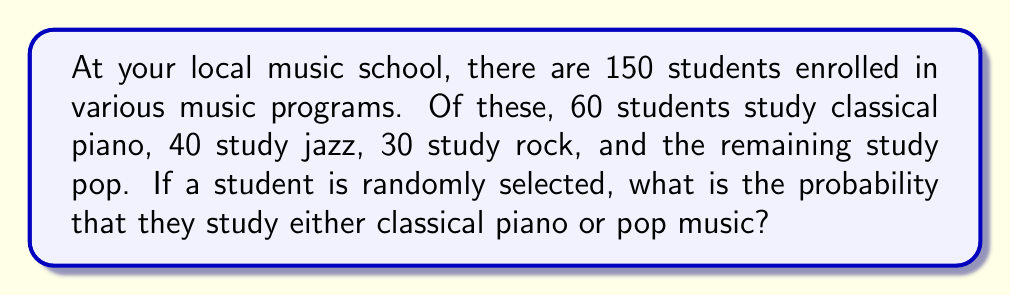Can you answer this question? Let's approach this step-by-step:

1. First, we need to determine how many students study pop music:
   Total students = 150
   Classical piano + Jazz + Rock + Pop = 150
   60 + 40 + 30 + Pop = 150
   Pop = 150 - 130 = 20 students

2. Now we know:
   Classical piano: 60 students
   Pop: 20 students

3. To find the probability of a student studying either classical piano or pop, we need to add these together:
   Students studying classical piano or pop = 60 + 20 = 80

4. The probability is calculated by dividing the number of favorable outcomes by the total number of possible outcomes:

   $$P(\text{Classical piano or Pop}) = \frac{\text{Number of students in Classical piano or Pop}}{\text{Total number of students}}$$

   $$P(\text{Classical piano or Pop}) = \frac{80}{150}$$

5. This fraction can be reduced:
   $$\frac{80}{150} = \frac{16}{30} = \frac{8}{15}$$

Therefore, the probability is $\frac{8}{15}$ or approximately 0.5333 or 53.33%.
Answer: $\frac{8}{15}$ or approximately 0.5333 or 53.33% 